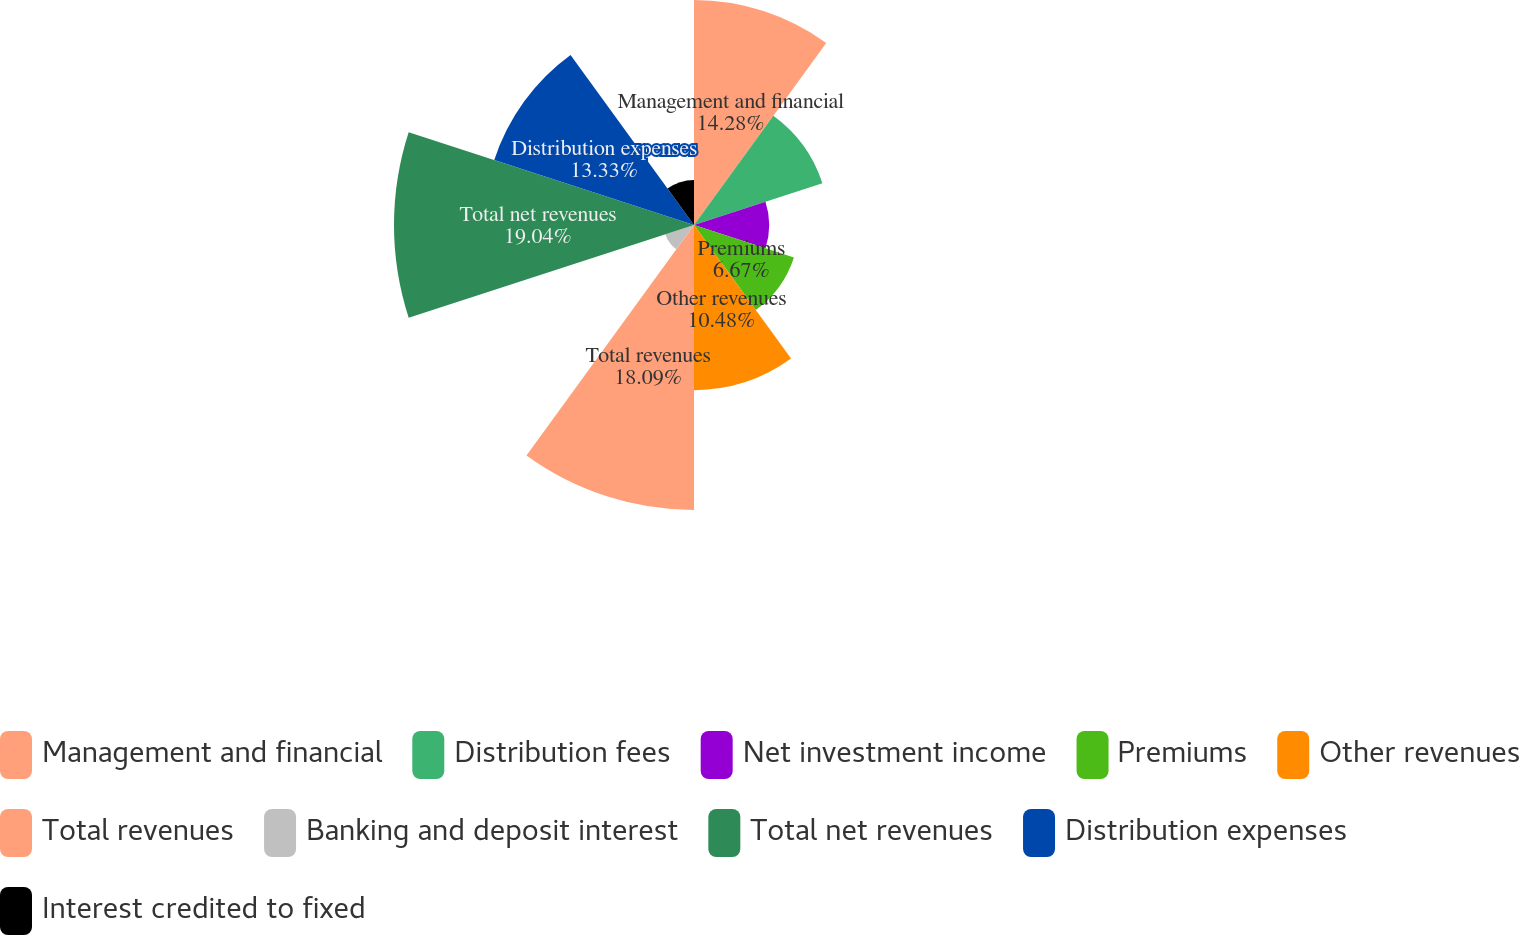<chart> <loc_0><loc_0><loc_500><loc_500><pie_chart><fcel>Management and financial<fcel>Distribution fees<fcel>Net investment income<fcel>Premiums<fcel>Other revenues<fcel>Total revenues<fcel>Banking and deposit interest<fcel>Total net revenues<fcel>Distribution expenses<fcel>Interest credited to fixed<nl><fcel>14.28%<fcel>8.57%<fcel>4.77%<fcel>6.67%<fcel>10.48%<fcel>18.09%<fcel>1.91%<fcel>19.04%<fcel>13.33%<fcel>2.86%<nl></chart> 